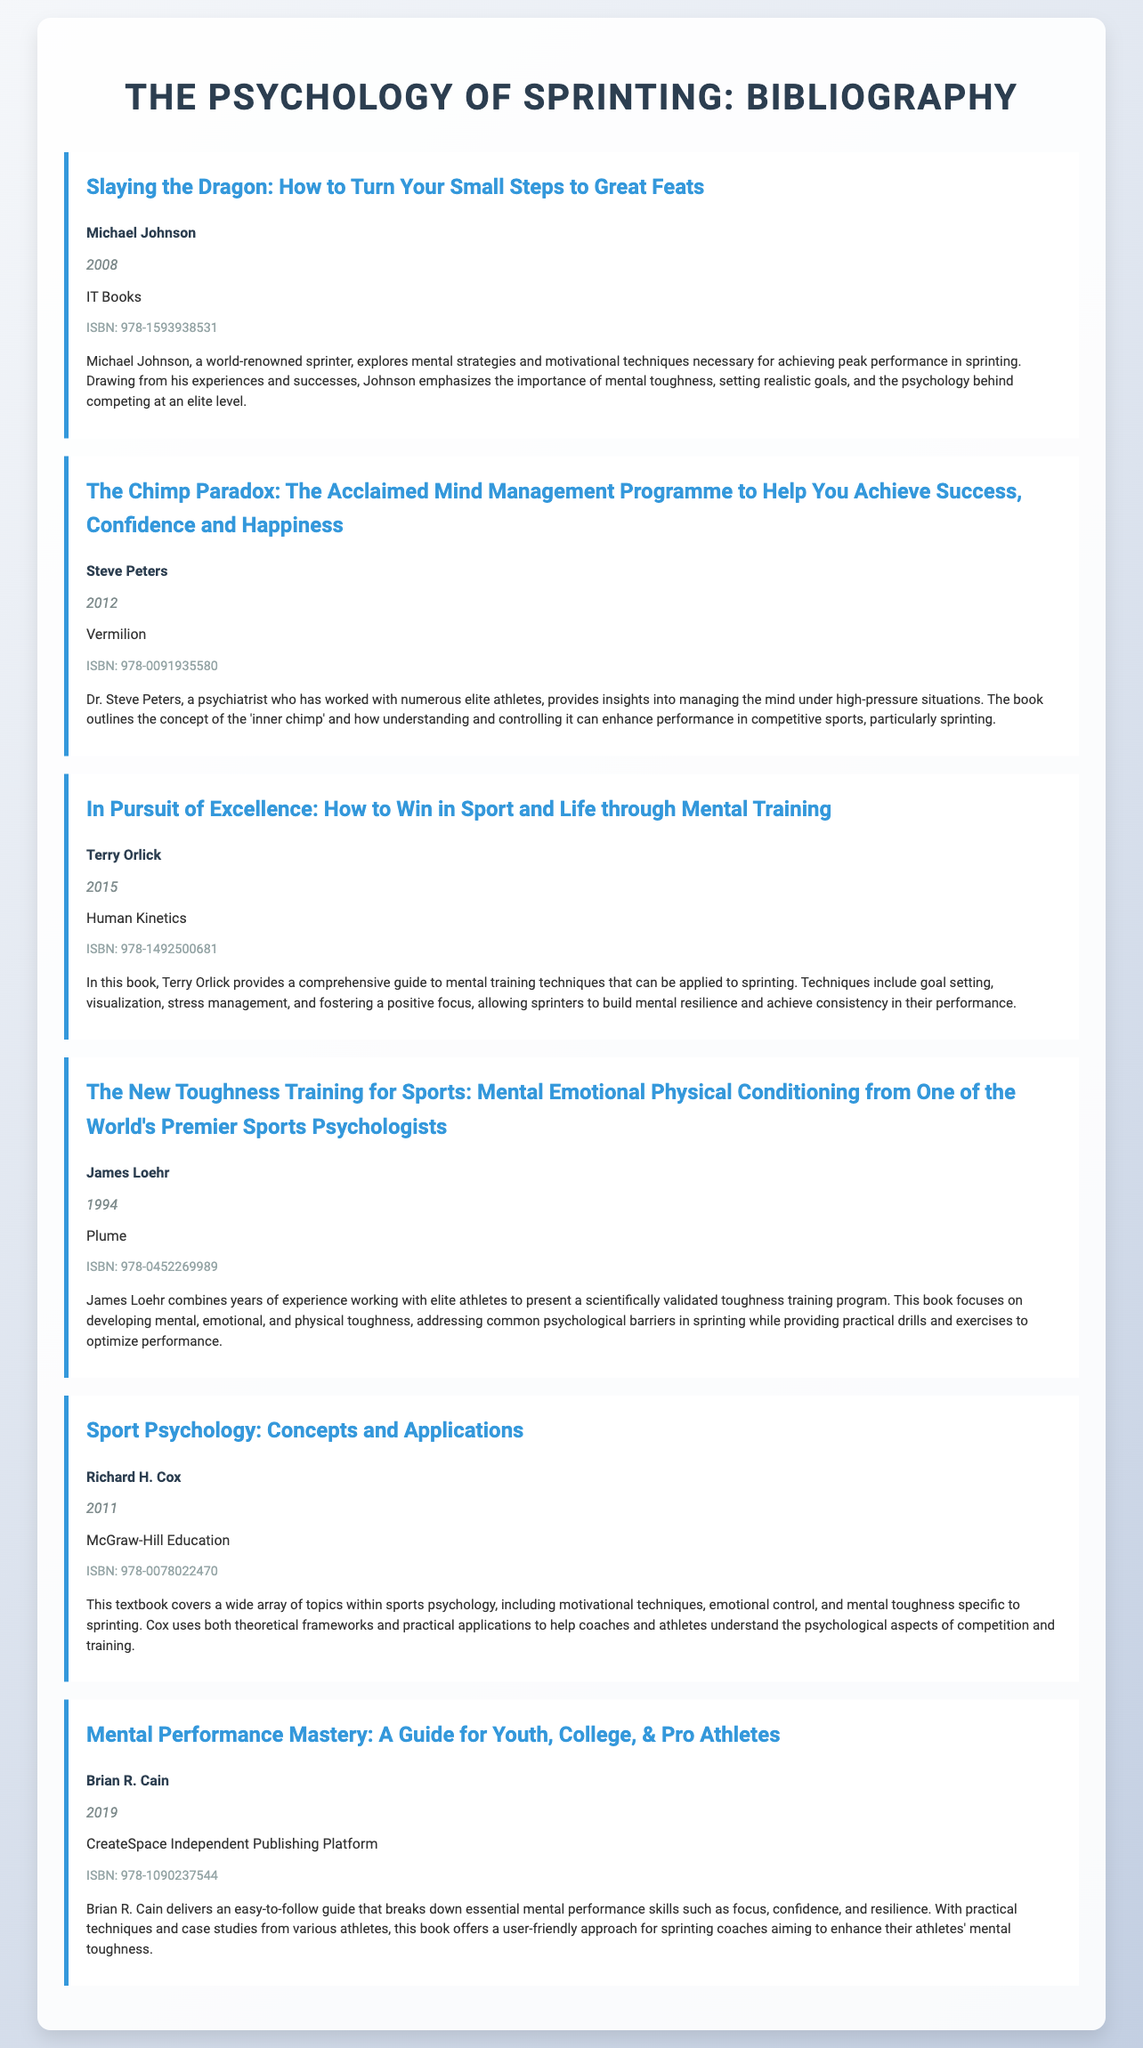What is the title of the first book? The title of the first book listed in the document is "Slaying the Dragon: How to Turn Your Small Steps to Great Feats."
Answer: Slaying the Dragon: How to Turn Your Small Steps to Great Feats Who is the author of "The Chimp Paradox"? The document states that Dr. Steve Peters is the author of "The Chimp Paradox."
Answer: Steve Peters What year was "In Pursuit of Excellence" published? The year of publication for "In Pursuit of Excellence" is mentioned as 2015 in the document.
Answer: 2015 What is the main focus of James Loehr's book? The document indicates that James Loehr's book focuses on developing mental, emotional, and physical toughness for athletes.
Answer: Mental, emotional, and physical toughness Which publisher released "Mental Performance Mastery"? The document lists CreateSpace Independent Publishing Platform as the publisher of "Mental Performance Mastery."
Answer: CreateSpace Independent Publishing Platform How many books are listed in total? The document presents a total of six books in the bibliography.
Answer: 6 What is one technique discussed by Terry Orlick for mental training? Among the techniques discussed by Terry Orlick, goal setting is specified in the document.
Answer: Goal setting Which book discusses the concept of the "inner chimp"? The book "The Chimp Paradox" is noted for discussing the concept of the "inner chimp."
Answer: The Chimp Paradox What kind of guide does Brian R. Cain provide in his book? The document describes Brian R. Cain's book as a guide for enhancing mental performance skills for athletes.
Answer: Guide for enhancing mental performance skills 